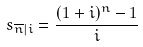Convert formula to latex. <formula><loc_0><loc_0><loc_500><loc_500>s _ { \overline { n } | i } = \frac { ( 1 + i ) ^ { n } - 1 } { i }</formula> 